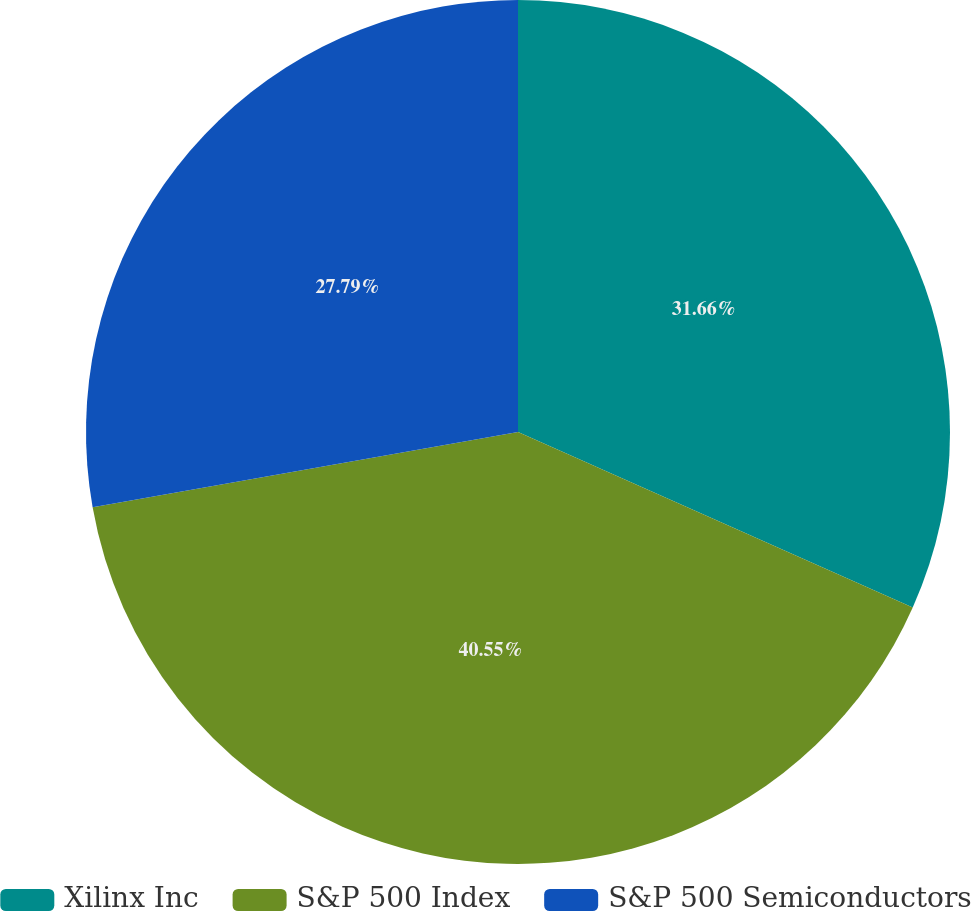Convert chart. <chart><loc_0><loc_0><loc_500><loc_500><pie_chart><fcel>Xilinx Inc<fcel>S&P 500 Index<fcel>S&P 500 Semiconductors<nl><fcel>31.66%<fcel>40.55%<fcel>27.79%<nl></chart> 